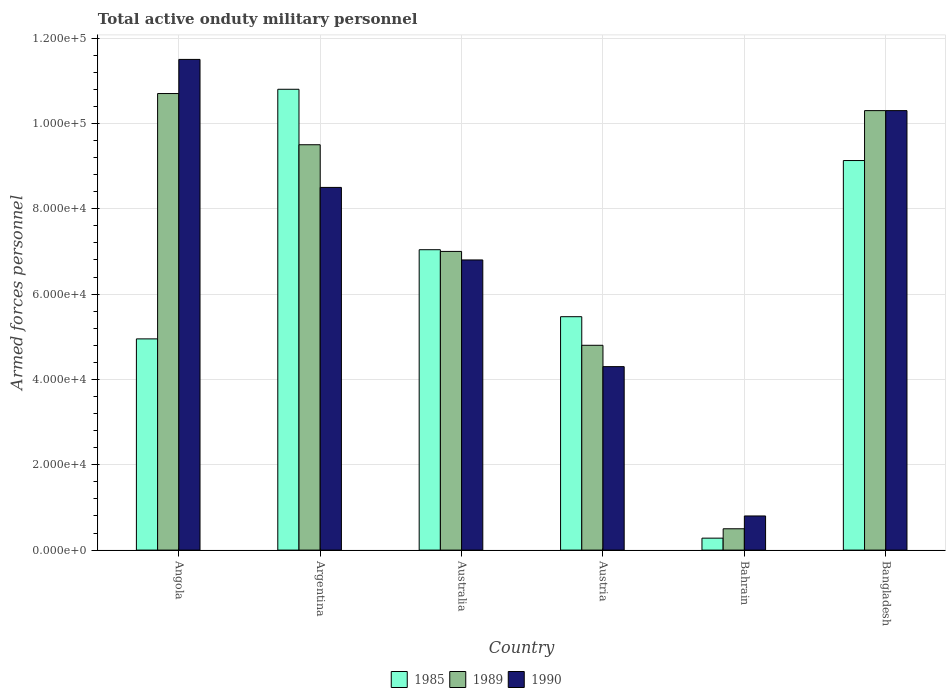How many different coloured bars are there?
Give a very brief answer. 3. Are the number of bars on each tick of the X-axis equal?
Offer a very short reply. Yes. How many bars are there on the 1st tick from the right?
Ensure brevity in your answer.  3. What is the label of the 5th group of bars from the left?
Your response must be concise. Bahrain. In how many cases, is the number of bars for a given country not equal to the number of legend labels?
Provide a short and direct response. 0. What is the number of armed forces personnel in 1990 in Australia?
Your answer should be compact. 6.80e+04. Across all countries, what is the maximum number of armed forces personnel in 1989?
Offer a terse response. 1.07e+05. Across all countries, what is the minimum number of armed forces personnel in 1985?
Provide a short and direct response. 2800. In which country was the number of armed forces personnel in 1989 maximum?
Your answer should be compact. Angola. In which country was the number of armed forces personnel in 1989 minimum?
Give a very brief answer. Bahrain. What is the total number of armed forces personnel in 1989 in the graph?
Offer a terse response. 4.28e+05. What is the difference between the number of armed forces personnel in 1989 in Austria and that in Bahrain?
Your answer should be compact. 4.30e+04. What is the difference between the number of armed forces personnel in 1989 in Australia and the number of armed forces personnel in 1990 in Argentina?
Make the answer very short. -1.50e+04. What is the average number of armed forces personnel in 1989 per country?
Provide a short and direct response. 7.13e+04. What is the difference between the number of armed forces personnel of/in 1985 and number of armed forces personnel of/in 1990 in Austria?
Ensure brevity in your answer.  1.17e+04. In how many countries, is the number of armed forces personnel in 1985 greater than 56000?
Your answer should be very brief. 3. What is the ratio of the number of armed forces personnel in 1985 in Austria to that in Bangladesh?
Provide a succinct answer. 0.6. Is the difference between the number of armed forces personnel in 1985 in Austria and Bahrain greater than the difference between the number of armed forces personnel in 1990 in Austria and Bahrain?
Keep it short and to the point. Yes. What is the difference between the highest and the second highest number of armed forces personnel in 1989?
Provide a short and direct response. 1.20e+04. What is the difference between the highest and the lowest number of armed forces personnel in 1985?
Your answer should be compact. 1.05e+05. Is the sum of the number of armed forces personnel in 1990 in Bahrain and Bangladesh greater than the maximum number of armed forces personnel in 1989 across all countries?
Your answer should be compact. Yes. What does the 1st bar from the left in Argentina represents?
Your response must be concise. 1985. What does the 2nd bar from the right in Bahrain represents?
Your answer should be compact. 1989. How many countries are there in the graph?
Make the answer very short. 6. Does the graph contain grids?
Keep it short and to the point. Yes. How many legend labels are there?
Provide a short and direct response. 3. How are the legend labels stacked?
Provide a short and direct response. Horizontal. What is the title of the graph?
Give a very brief answer. Total active onduty military personnel. What is the label or title of the Y-axis?
Keep it short and to the point. Armed forces personnel. What is the Armed forces personnel of 1985 in Angola?
Provide a short and direct response. 4.95e+04. What is the Armed forces personnel in 1989 in Angola?
Provide a succinct answer. 1.07e+05. What is the Armed forces personnel in 1990 in Angola?
Offer a terse response. 1.15e+05. What is the Armed forces personnel in 1985 in Argentina?
Offer a very short reply. 1.08e+05. What is the Armed forces personnel in 1989 in Argentina?
Give a very brief answer. 9.50e+04. What is the Armed forces personnel in 1990 in Argentina?
Offer a terse response. 8.50e+04. What is the Armed forces personnel of 1985 in Australia?
Provide a short and direct response. 7.04e+04. What is the Armed forces personnel in 1990 in Australia?
Your answer should be compact. 6.80e+04. What is the Armed forces personnel in 1985 in Austria?
Keep it short and to the point. 5.47e+04. What is the Armed forces personnel of 1989 in Austria?
Your response must be concise. 4.80e+04. What is the Armed forces personnel in 1990 in Austria?
Your answer should be compact. 4.30e+04. What is the Armed forces personnel in 1985 in Bahrain?
Give a very brief answer. 2800. What is the Armed forces personnel in 1989 in Bahrain?
Ensure brevity in your answer.  5000. What is the Armed forces personnel in 1990 in Bahrain?
Keep it short and to the point. 8000. What is the Armed forces personnel of 1985 in Bangladesh?
Your answer should be very brief. 9.13e+04. What is the Armed forces personnel in 1989 in Bangladesh?
Provide a succinct answer. 1.03e+05. What is the Armed forces personnel of 1990 in Bangladesh?
Offer a terse response. 1.03e+05. Across all countries, what is the maximum Armed forces personnel in 1985?
Provide a short and direct response. 1.08e+05. Across all countries, what is the maximum Armed forces personnel in 1989?
Keep it short and to the point. 1.07e+05. Across all countries, what is the maximum Armed forces personnel of 1990?
Ensure brevity in your answer.  1.15e+05. Across all countries, what is the minimum Armed forces personnel of 1985?
Offer a terse response. 2800. Across all countries, what is the minimum Armed forces personnel of 1990?
Offer a terse response. 8000. What is the total Armed forces personnel in 1985 in the graph?
Provide a short and direct response. 3.77e+05. What is the total Armed forces personnel in 1989 in the graph?
Keep it short and to the point. 4.28e+05. What is the total Armed forces personnel in 1990 in the graph?
Provide a succinct answer. 4.22e+05. What is the difference between the Armed forces personnel in 1985 in Angola and that in Argentina?
Keep it short and to the point. -5.85e+04. What is the difference between the Armed forces personnel of 1989 in Angola and that in Argentina?
Ensure brevity in your answer.  1.20e+04. What is the difference between the Armed forces personnel in 1985 in Angola and that in Australia?
Make the answer very short. -2.09e+04. What is the difference between the Armed forces personnel of 1989 in Angola and that in Australia?
Your answer should be compact. 3.70e+04. What is the difference between the Armed forces personnel of 1990 in Angola and that in Australia?
Your response must be concise. 4.70e+04. What is the difference between the Armed forces personnel in 1985 in Angola and that in Austria?
Provide a short and direct response. -5200. What is the difference between the Armed forces personnel in 1989 in Angola and that in Austria?
Provide a succinct answer. 5.90e+04. What is the difference between the Armed forces personnel of 1990 in Angola and that in Austria?
Your answer should be compact. 7.20e+04. What is the difference between the Armed forces personnel of 1985 in Angola and that in Bahrain?
Offer a terse response. 4.67e+04. What is the difference between the Armed forces personnel of 1989 in Angola and that in Bahrain?
Your response must be concise. 1.02e+05. What is the difference between the Armed forces personnel of 1990 in Angola and that in Bahrain?
Ensure brevity in your answer.  1.07e+05. What is the difference between the Armed forces personnel in 1985 in Angola and that in Bangladesh?
Provide a short and direct response. -4.18e+04. What is the difference between the Armed forces personnel of 1989 in Angola and that in Bangladesh?
Provide a short and direct response. 4000. What is the difference between the Armed forces personnel of 1990 in Angola and that in Bangladesh?
Make the answer very short. 1.20e+04. What is the difference between the Armed forces personnel of 1985 in Argentina and that in Australia?
Provide a short and direct response. 3.76e+04. What is the difference between the Armed forces personnel of 1989 in Argentina and that in Australia?
Provide a succinct answer. 2.50e+04. What is the difference between the Armed forces personnel in 1990 in Argentina and that in Australia?
Make the answer very short. 1.70e+04. What is the difference between the Armed forces personnel in 1985 in Argentina and that in Austria?
Offer a very short reply. 5.33e+04. What is the difference between the Armed forces personnel in 1989 in Argentina and that in Austria?
Give a very brief answer. 4.70e+04. What is the difference between the Armed forces personnel in 1990 in Argentina and that in Austria?
Your response must be concise. 4.20e+04. What is the difference between the Armed forces personnel in 1985 in Argentina and that in Bahrain?
Make the answer very short. 1.05e+05. What is the difference between the Armed forces personnel of 1989 in Argentina and that in Bahrain?
Keep it short and to the point. 9.00e+04. What is the difference between the Armed forces personnel of 1990 in Argentina and that in Bahrain?
Ensure brevity in your answer.  7.70e+04. What is the difference between the Armed forces personnel in 1985 in Argentina and that in Bangladesh?
Offer a terse response. 1.67e+04. What is the difference between the Armed forces personnel of 1989 in Argentina and that in Bangladesh?
Keep it short and to the point. -8000. What is the difference between the Armed forces personnel in 1990 in Argentina and that in Bangladesh?
Your answer should be compact. -1.80e+04. What is the difference between the Armed forces personnel of 1985 in Australia and that in Austria?
Your answer should be very brief. 1.57e+04. What is the difference between the Armed forces personnel in 1989 in Australia and that in Austria?
Keep it short and to the point. 2.20e+04. What is the difference between the Armed forces personnel in 1990 in Australia and that in Austria?
Your response must be concise. 2.50e+04. What is the difference between the Armed forces personnel in 1985 in Australia and that in Bahrain?
Keep it short and to the point. 6.76e+04. What is the difference between the Armed forces personnel of 1989 in Australia and that in Bahrain?
Your answer should be compact. 6.50e+04. What is the difference between the Armed forces personnel of 1990 in Australia and that in Bahrain?
Your answer should be very brief. 6.00e+04. What is the difference between the Armed forces personnel of 1985 in Australia and that in Bangladesh?
Offer a very short reply. -2.09e+04. What is the difference between the Armed forces personnel in 1989 in Australia and that in Bangladesh?
Provide a short and direct response. -3.30e+04. What is the difference between the Armed forces personnel of 1990 in Australia and that in Bangladesh?
Keep it short and to the point. -3.50e+04. What is the difference between the Armed forces personnel of 1985 in Austria and that in Bahrain?
Give a very brief answer. 5.19e+04. What is the difference between the Armed forces personnel in 1989 in Austria and that in Bahrain?
Your answer should be compact. 4.30e+04. What is the difference between the Armed forces personnel of 1990 in Austria and that in Bahrain?
Offer a terse response. 3.50e+04. What is the difference between the Armed forces personnel of 1985 in Austria and that in Bangladesh?
Offer a terse response. -3.66e+04. What is the difference between the Armed forces personnel in 1989 in Austria and that in Bangladesh?
Provide a succinct answer. -5.50e+04. What is the difference between the Armed forces personnel of 1990 in Austria and that in Bangladesh?
Keep it short and to the point. -6.00e+04. What is the difference between the Armed forces personnel in 1985 in Bahrain and that in Bangladesh?
Your response must be concise. -8.85e+04. What is the difference between the Armed forces personnel in 1989 in Bahrain and that in Bangladesh?
Keep it short and to the point. -9.80e+04. What is the difference between the Armed forces personnel in 1990 in Bahrain and that in Bangladesh?
Offer a very short reply. -9.50e+04. What is the difference between the Armed forces personnel of 1985 in Angola and the Armed forces personnel of 1989 in Argentina?
Your answer should be compact. -4.55e+04. What is the difference between the Armed forces personnel in 1985 in Angola and the Armed forces personnel in 1990 in Argentina?
Keep it short and to the point. -3.55e+04. What is the difference between the Armed forces personnel of 1989 in Angola and the Armed forces personnel of 1990 in Argentina?
Offer a very short reply. 2.20e+04. What is the difference between the Armed forces personnel in 1985 in Angola and the Armed forces personnel in 1989 in Australia?
Provide a short and direct response. -2.05e+04. What is the difference between the Armed forces personnel in 1985 in Angola and the Armed forces personnel in 1990 in Australia?
Provide a succinct answer. -1.85e+04. What is the difference between the Armed forces personnel in 1989 in Angola and the Armed forces personnel in 1990 in Australia?
Ensure brevity in your answer.  3.90e+04. What is the difference between the Armed forces personnel in 1985 in Angola and the Armed forces personnel in 1989 in Austria?
Keep it short and to the point. 1500. What is the difference between the Armed forces personnel of 1985 in Angola and the Armed forces personnel of 1990 in Austria?
Give a very brief answer. 6500. What is the difference between the Armed forces personnel of 1989 in Angola and the Armed forces personnel of 1990 in Austria?
Keep it short and to the point. 6.40e+04. What is the difference between the Armed forces personnel in 1985 in Angola and the Armed forces personnel in 1989 in Bahrain?
Your answer should be compact. 4.45e+04. What is the difference between the Armed forces personnel in 1985 in Angola and the Armed forces personnel in 1990 in Bahrain?
Make the answer very short. 4.15e+04. What is the difference between the Armed forces personnel of 1989 in Angola and the Armed forces personnel of 1990 in Bahrain?
Make the answer very short. 9.90e+04. What is the difference between the Armed forces personnel of 1985 in Angola and the Armed forces personnel of 1989 in Bangladesh?
Give a very brief answer. -5.35e+04. What is the difference between the Armed forces personnel in 1985 in Angola and the Armed forces personnel in 1990 in Bangladesh?
Keep it short and to the point. -5.35e+04. What is the difference between the Armed forces personnel of 1989 in Angola and the Armed forces personnel of 1990 in Bangladesh?
Make the answer very short. 4000. What is the difference between the Armed forces personnel in 1985 in Argentina and the Armed forces personnel in 1989 in Australia?
Your answer should be compact. 3.80e+04. What is the difference between the Armed forces personnel in 1985 in Argentina and the Armed forces personnel in 1990 in Australia?
Offer a terse response. 4.00e+04. What is the difference between the Armed forces personnel in 1989 in Argentina and the Armed forces personnel in 1990 in Australia?
Your answer should be very brief. 2.70e+04. What is the difference between the Armed forces personnel of 1985 in Argentina and the Armed forces personnel of 1989 in Austria?
Provide a short and direct response. 6.00e+04. What is the difference between the Armed forces personnel of 1985 in Argentina and the Armed forces personnel of 1990 in Austria?
Ensure brevity in your answer.  6.50e+04. What is the difference between the Armed forces personnel in 1989 in Argentina and the Armed forces personnel in 1990 in Austria?
Your answer should be compact. 5.20e+04. What is the difference between the Armed forces personnel of 1985 in Argentina and the Armed forces personnel of 1989 in Bahrain?
Make the answer very short. 1.03e+05. What is the difference between the Armed forces personnel in 1985 in Argentina and the Armed forces personnel in 1990 in Bahrain?
Keep it short and to the point. 1.00e+05. What is the difference between the Armed forces personnel in 1989 in Argentina and the Armed forces personnel in 1990 in Bahrain?
Ensure brevity in your answer.  8.70e+04. What is the difference between the Armed forces personnel in 1985 in Argentina and the Armed forces personnel in 1990 in Bangladesh?
Offer a very short reply. 5000. What is the difference between the Armed forces personnel of 1989 in Argentina and the Armed forces personnel of 1990 in Bangladesh?
Give a very brief answer. -8000. What is the difference between the Armed forces personnel of 1985 in Australia and the Armed forces personnel of 1989 in Austria?
Offer a very short reply. 2.24e+04. What is the difference between the Armed forces personnel in 1985 in Australia and the Armed forces personnel in 1990 in Austria?
Provide a succinct answer. 2.74e+04. What is the difference between the Armed forces personnel in 1989 in Australia and the Armed forces personnel in 1990 in Austria?
Provide a succinct answer. 2.70e+04. What is the difference between the Armed forces personnel of 1985 in Australia and the Armed forces personnel of 1989 in Bahrain?
Keep it short and to the point. 6.54e+04. What is the difference between the Armed forces personnel of 1985 in Australia and the Armed forces personnel of 1990 in Bahrain?
Offer a very short reply. 6.24e+04. What is the difference between the Armed forces personnel of 1989 in Australia and the Armed forces personnel of 1990 in Bahrain?
Provide a short and direct response. 6.20e+04. What is the difference between the Armed forces personnel in 1985 in Australia and the Armed forces personnel in 1989 in Bangladesh?
Your answer should be very brief. -3.26e+04. What is the difference between the Armed forces personnel of 1985 in Australia and the Armed forces personnel of 1990 in Bangladesh?
Your answer should be compact. -3.26e+04. What is the difference between the Armed forces personnel of 1989 in Australia and the Armed forces personnel of 1990 in Bangladesh?
Keep it short and to the point. -3.30e+04. What is the difference between the Armed forces personnel in 1985 in Austria and the Armed forces personnel in 1989 in Bahrain?
Offer a very short reply. 4.97e+04. What is the difference between the Armed forces personnel in 1985 in Austria and the Armed forces personnel in 1990 in Bahrain?
Offer a very short reply. 4.67e+04. What is the difference between the Armed forces personnel of 1989 in Austria and the Armed forces personnel of 1990 in Bahrain?
Your answer should be very brief. 4.00e+04. What is the difference between the Armed forces personnel in 1985 in Austria and the Armed forces personnel in 1989 in Bangladesh?
Offer a very short reply. -4.83e+04. What is the difference between the Armed forces personnel of 1985 in Austria and the Armed forces personnel of 1990 in Bangladesh?
Ensure brevity in your answer.  -4.83e+04. What is the difference between the Armed forces personnel in 1989 in Austria and the Armed forces personnel in 1990 in Bangladesh?
Your response must be concise. -5.50e+04. What is the difference between the Armed forces personnel of 1985 in Bahrain and the Armed forces personnel of 1989 in Bangladesh?
Give a very brief answer. -1.00e+05. What is the difference between the Armed forces personnel of 1985 in Bahrain and the Armed forces personnel of 1990 in Bangladesh?
Give a very brief answer. -1.00e+05. What is the difference between the Armed forces personnel in 1989 in Bahrain and the Armed forces personnel in 1990 in Bangladesh?
Make the answer very short. -9.80e+04. What is the average Armed forces personnel in 1985 per country?
Offer a terse response. 6.28e+04. What is the average Armed forces personnel of 1989 per country?
Ensure brevity in your answer.  7.13e+04. What is the average Armed forces personnel of 1990 per country?
Make the answer very short. 7.03e+04. What is the difference between the Armed forces personnel in 1985 and Armed forces personnel in 1989 in Angola?
Offer a very short reply. -5.75e+04. What is the difference between the Armed forces personnel of 1985 and Armed forces personnel of 1990 in Angola?
Offer a very short reply. -6.55e+04. What is the difference between the Armed forces personnel in 1989 and Armed forces personnel in 1990 in Angola?
Ensure brevity in your answer.  -8000. What is the difference between the Armed forces personnel in 1985 and Armed forces personnel in 1989 in Argentina?
Give a very brief answer. 1.30e+04. What is the difference between the Armed forces personnel in 1985 and Armed forces personnel in 1990 in Argentina?
Offer a terse response. 2.30e+04. What is the difference between the Armed forces personnel in 1989 and Armed forces personnel in 1990 in Argentina?
Keep it short and to the point. 10000. What is the difference between the Armed forces personnel in 1985 and Armed forces personnel in 1989 in Australia?
Offer a very short reply. 400. What is the difference between the Armed forces personnel in 1985 and Armed forces personnel in 1990 in Australia?
Your answer should be compact. 2400. What is the difference between the Armed forces personnel in 1985 and Armed forces personnel in 1989 in Austria?
Make the answer very short. 6700. What is the difference between the Armed forces personnel in 1985 and Armed forces personnel in 1990 in Austria?
Ensure brevity in your answer.  1.17e+04. What is the difference between the Armed forces personnel of 1985 and Armed forces personnel of 1989 in Bahrain?
Your answer should be very brief. -2200. What is the difference between the Armed forces personnel of 1985 and Armed forces personnel of 1990 in Bahrain?
Provide a short and direct response. -5200. What is the difference between the Armed forces personnel of 1989 and Armed forces personnel of 1990 in Bahrain?
Ensure brevity in your answer.  -3000. What is the difference between the Armed forces personnel of 1985 and Armed forces personnel of 1989 in Bangladesh?
Give a very brief answer. -1.17e+04. What is the difference between the Armed forces personnel in 1985 and Armed forces personnel in 1990 in Bangladesh?
Your response must be concise. -1.17e+04. What is the difference between the Armed forces personnel in 1989 and Armed forces personnel in 1990 in Bangladesh?
Your answer should be compact. 0. What is the ratio of the Armed forces personnel of 1985 in Angola to that in Argentina?
Make the answer very short. 0.46. What is the ratio of the Armed forces personnel in 1989 in Angola to that in Argentina?
Offer a terse response. 1.13. What is the ratio of the Armed forces personnel of 1990 in Angola to that in Argentina?
Your answer should be compact. 1.35. What is the ratio of the Armed forces personnel of 1985 in Angola to that in Australia?
Offer a terse response. 0.7. What is the ratio of the Armed forces personnel in 1989 in Angola to that in Australia?
Provide a short and direct response. 1.53. What is the ratio of the Armed forces personnel of 1990 in Angola to that in Australia?
Make the answer very short. 1.69. What is the ratio of the Armed forces personnel in 1985 in Angola to that in Austria?
Give a very brief answer. 0.9. What is the ratio of the Armed forces personnel in 1989 in Angola to that in Austria?
Give a very brief answer. 2.23. What is the ratio of the Armed forces personnel of 1990 in Angola to that in Austria?
Provide a succinct answer. 2.67. What is the ratio of the Armed forces personnel in 1985 in Angola to that in Bahrain?
Your answer should be very brief. 17.68. What is the ratio of the Armed forces personnel of 1989 in Angola to that in Bahrain?
Keep it short and to the point. 21.4. What is the ratio of the Armed forces personnel in 1990 in Angola to that in Bahrain?
Offer a terse response. 14.38. What is the ratio of the Armed forces personnel of 1985 in Angola to that in Bangladesh?
Provide a succinct answer. 0.54. What is the ratio of the Armed forces personnel in 1989 in Angola to that in Bangladesh?
Keep it short and to the point. 1.04. What is the ratio of the Armed forces personnel of 1990 in Angola to that in Bangladesh?
Provide a short and direct response. 1.12. What is the ratio of the Armed forces personnel of 1985 in Argentina to that in Australia?
Your response must be concise. 1.53. What is the ratio of the Armed forces personnel in 1989 in Argentina to that in Australia?
Make the answer very short. 1.36. What is the ratio of the Armed forces personnel of 1990 in Argentina to that in Australia?
Make the answer very short. 1.25. What is the ratio of the Armed forces personnel of 1985 in Argentina to that in Austria?
Offer a very short reply. 1.97. What is the ratio of the Armed forces personnel in 1989 in Argentina to that in Austria?
Provide a succinct answer. 1.98. What is the ratio of the Armed forces personnel of 1990 in Argentina to that in Austria?
Ensure brevity in your answer.  1.98. What is the ratio of the Armed forces personnel of 1985 in Argentina to that in Bahrain?
Offer a terse response. 38.57. What is the ratio of the Armed forces personnel of 1990 in Argentina to that in Bahrain?
Your response must be concise. 10.62. What is the ratio of the Armed forces personnel of 1985 in Argentina to that in Bangladesh?
Keep it short and to the point. 1.18. What is the ratio of the Armed forces personnel of 1989 in Argentina to that in Bangladesh?
Provide a succinct answer. 0.92. What is the ratio of the Armed forces personnel in 1990 in Argentina to that in Bangladesh?
Make the answer very short. 0.83. What is the ratio of the Armed forces personnel of 1985 in Australia to that in Austria?
Provide a succinct answer. 1.29. What is the ratio of the Armed forces personnel in 1989 in Australia to that in Austria?
Your answer should be very brief. 1.46. What is the ratio of the Armed forces personnel in 1990 in Australia to that in Austria?
Ensure brevity in your answer.  1.58. What is the ratio of the Armed forces personnel in 1985 in Australia to that in Bahrain?
Your response must be concise. 25.14. What is the ratio of the Armed forces personnel in 1989 in Australia to that in Bahrain?
Ensure brevity in your answer.  14. What is the ratio of the Armed forces personnel in 1990 in Australia to that in Bahrain?
Keep it short and to the point. 8.5. What is the ratio of the Armed forces personnel of 1985 in Australia to that in Bangladesh?
Offer a terse response. 0.77. What is the ratio of the Armed forces personnel in 1989 in Australia to that in Bangladesh?
Provide a succinct answer. 0.68. What is the ratio of the Armed forces personnel in 1990 in Australia to that in Bangladesh?
Give a very brief answer. 0.66. What is the ratio of the Armed forces personnel in 1985 in Austria to that in Bahrain?
Your answer should be very brief. 19.54. What is the ratio of the Armed forces personnel of 1990 in Austria to that in Bahrain?
Provide a short and direct response. 5.38. What is the ratio of the Armed forces personnel in 1985 in Austria to that in Bangladesh?
Your response must be concise. 0.6. What is the ratio of the Armed forces personnel of 1989 in Austria to that in Bangladesh?
Give a very brief answer. 0.47. What is the ratio of the Armed forces personnel of 1990 in Austria to that in Bangladesh?
Provide a succinct answer. 0.42. What is the ratio of the Armed forces personnel in 1985 in Bahrain to that in Bangladesh?
Your answer should be very brief. 0.03. What is the ratio of the Armed forces personnel of 1989 in Bahrain to that in Bangladesh?
Offer a terse response. 0.05. What is the ratio of the Armed forces personnel in 1990 in Bahrain to that in Bangladesh?
Offer a terse response. 0.08. What is the difference between the highest and the second highest Armed forces personnel of 1985?
Keep it short and to the point. 1.67e+04. What is the difference between the highest and the second highest Armed forces personnel of 1989?
Your answer should be compact. 4000. What is the difference between the highest and the second highest Armed forces personnel in 1990?
Provide a succinct answer. 1.20e+04. What is the difference between the highest and the lowest Armed forces personnel in 1985?
Your answer should be very brief. 1.05e+05. What is the difference between the highest and the lowest Armed forces personnel in 1989?
Offer a terse response. 1.02e+05. What is the difference between the highest and the lowest Armed forces personnel in 1990?
Your answer should be very brief. 1.07e+05. 